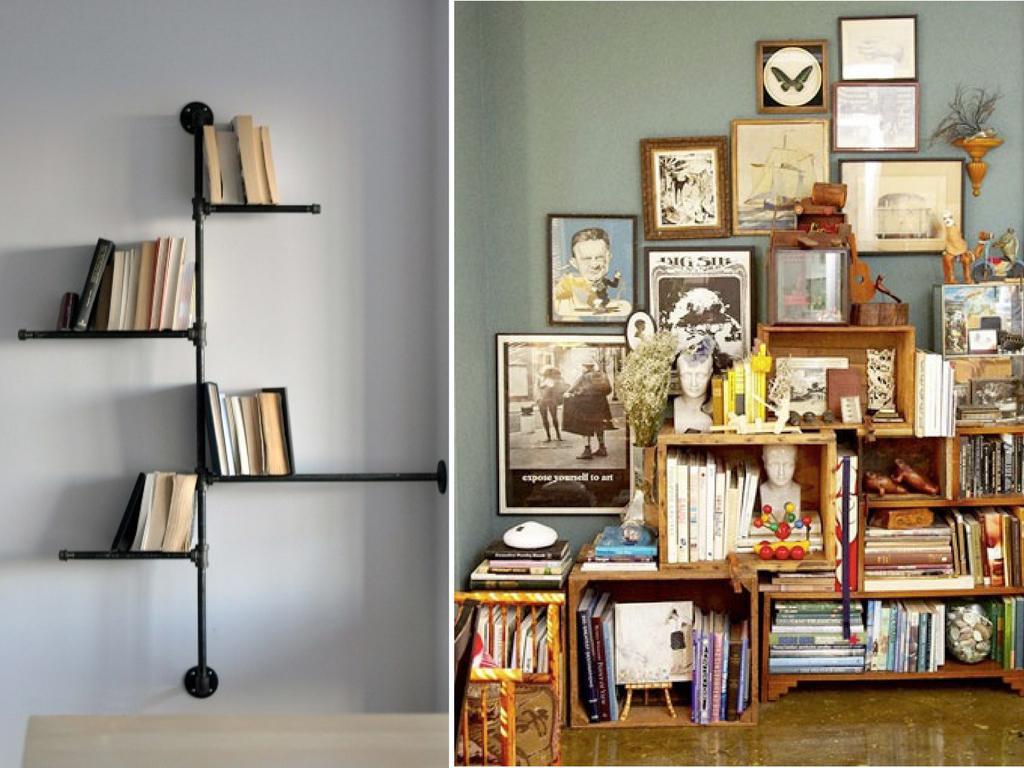Could you give a brief overview of what you see in this image? I see this is a collage image and I see number books on the shelves and I see few photo frames over here and I see the floor. In the background I see the wall and I see few things over here. 